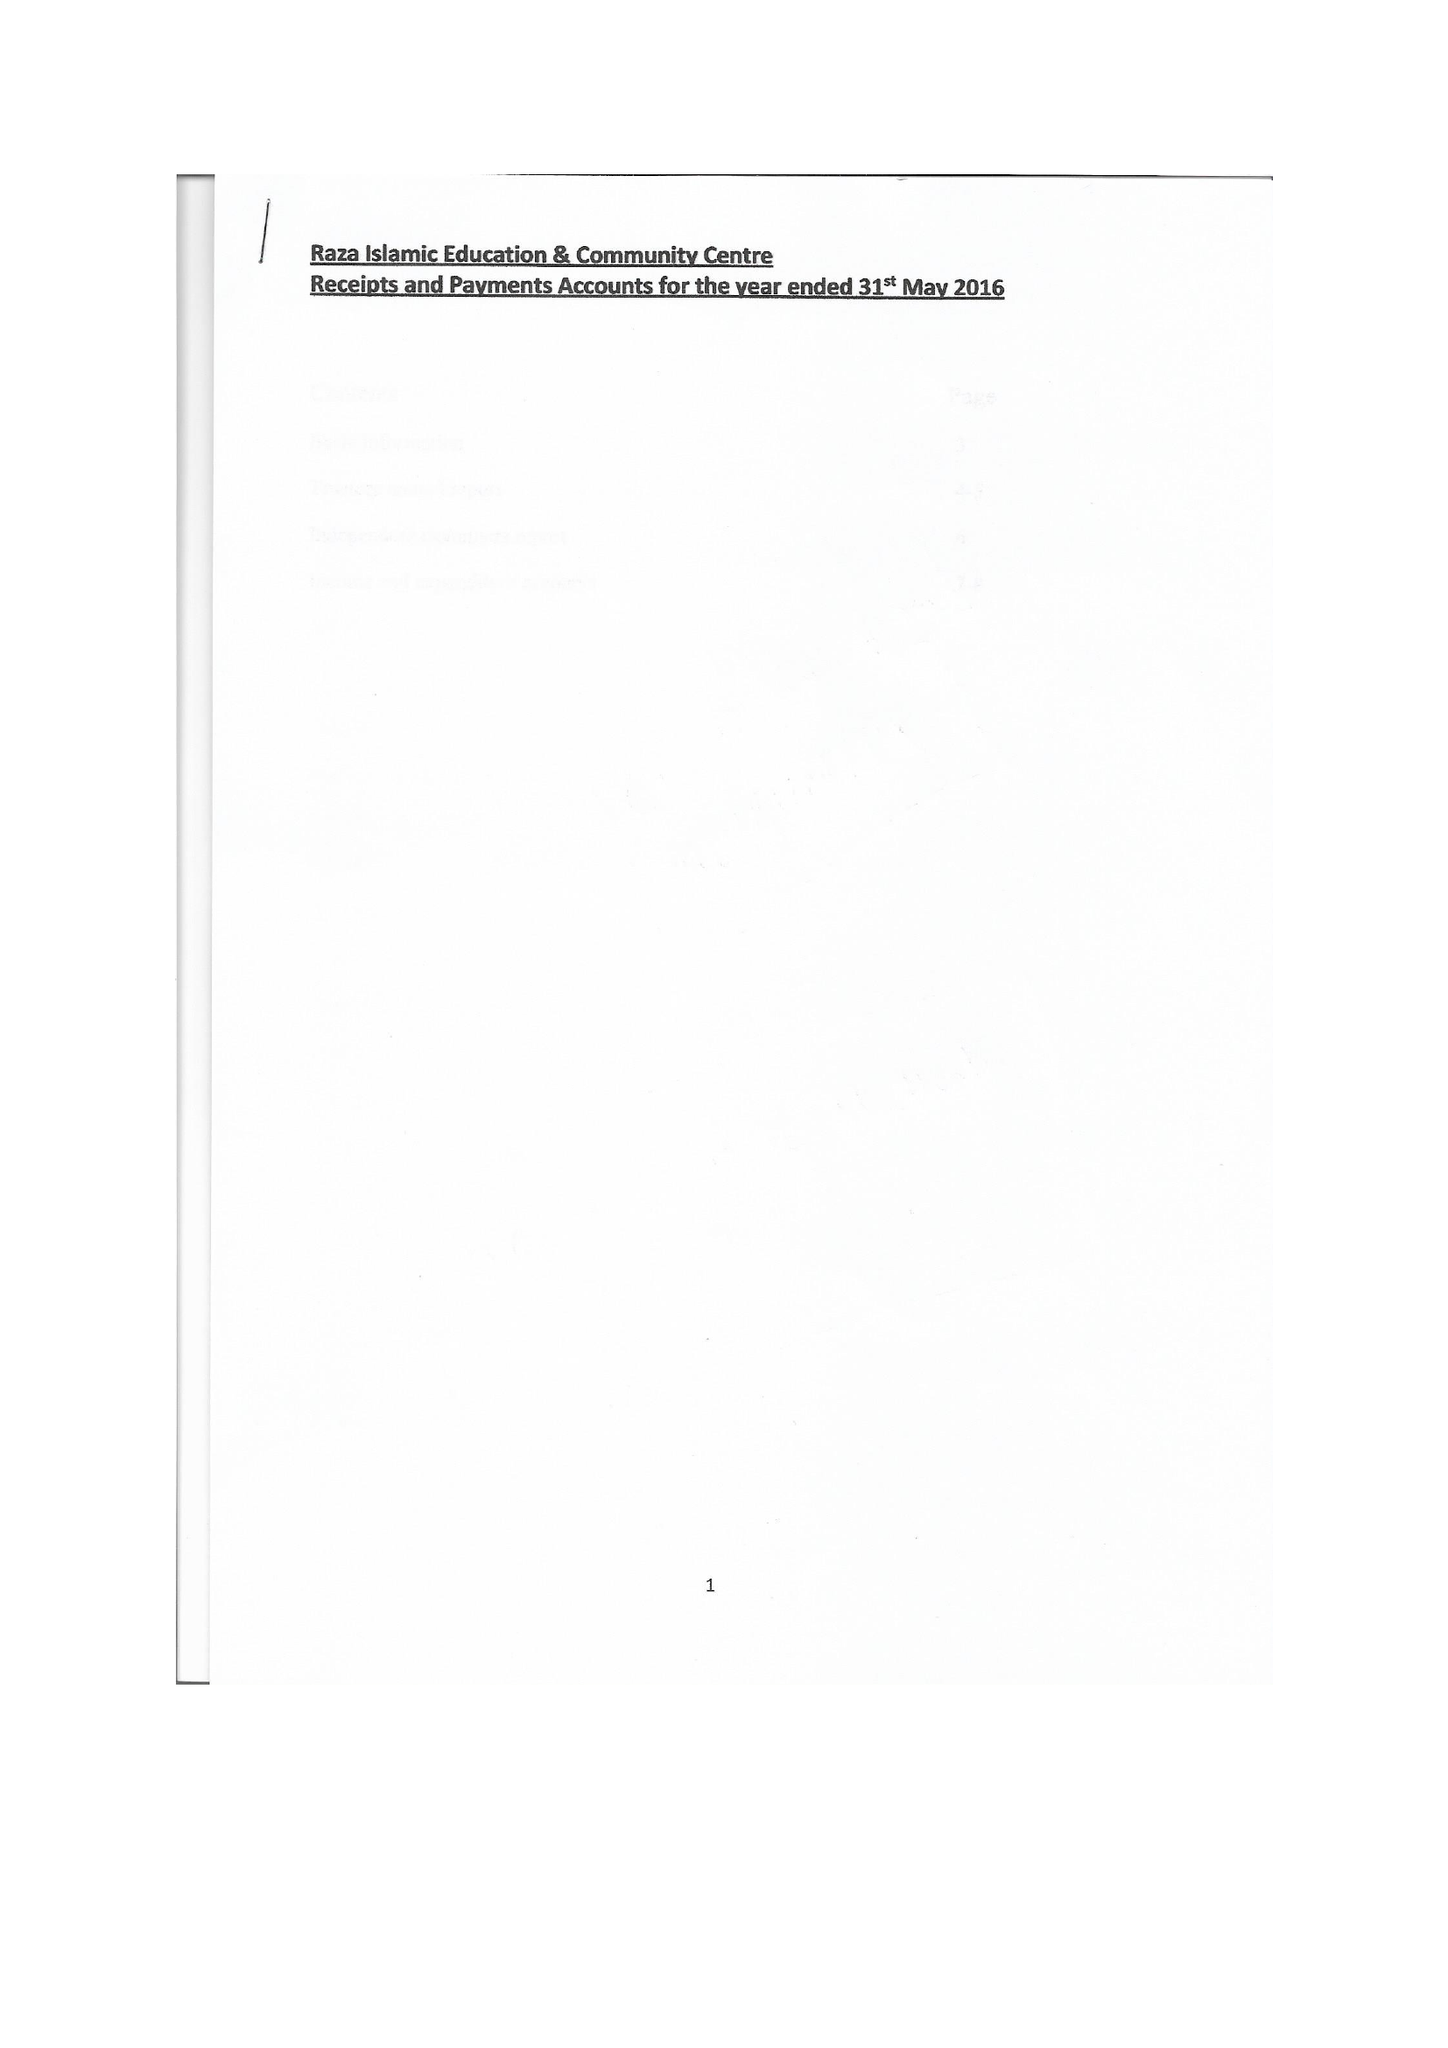What is the value for the address__street_line?
Answer the question using a single word or phrase. 399 LEES HALL ROAD 